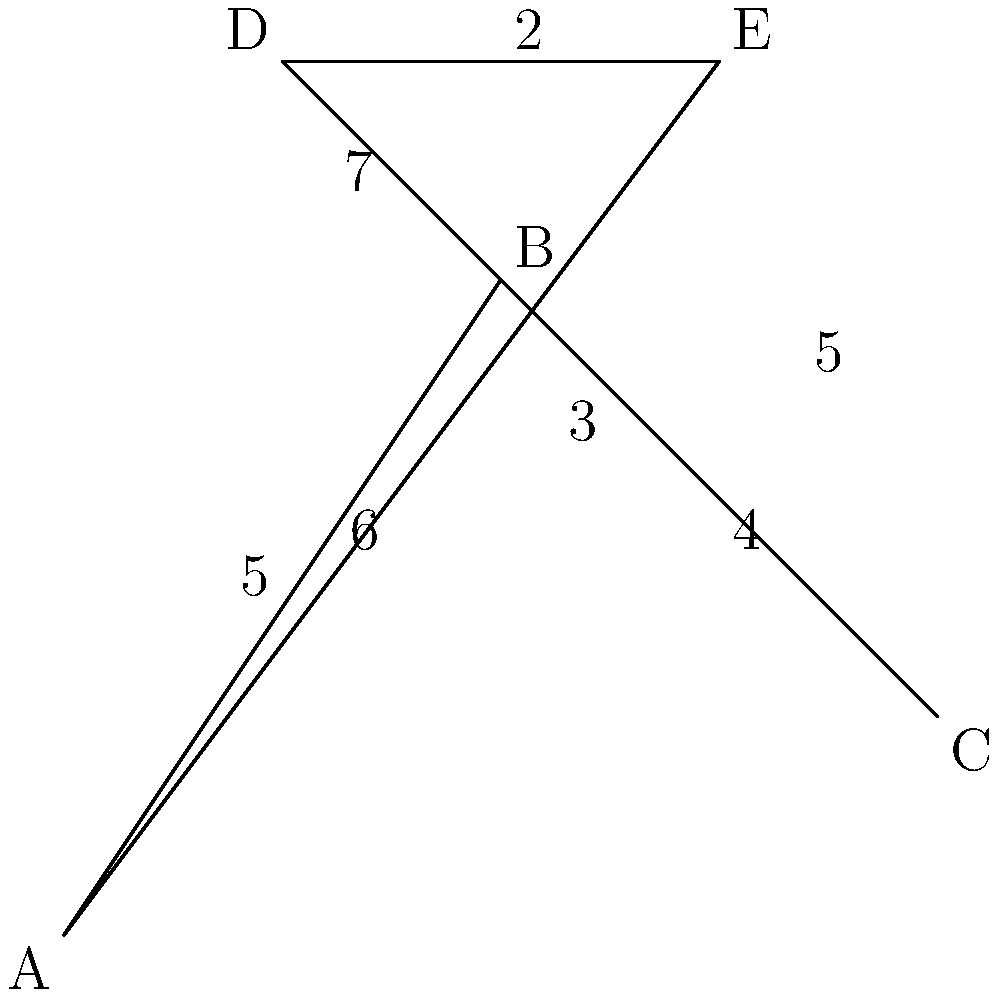Given the map of coffee bean distribution centers (A, B, C, D, E) with distances between them, what is the shortest route that visits all centers exactly once and returns to the starting point? Provide the route and its total distance. To solve this problem, we need to find the shortest Hamiltonian cycle, also known as the Traveling Salesman Problem (TSP). Here's a step-by-step approach:

1. Identify all possible routes:
   There are $(5-1)! = 24$ possible routes, as we can start from any point.

2. Calculate the distance for each route:
   For example, A-B-C-D-E-A = 5 + 4 + 3 + 2 + 6 = 20

3. Compare all routes to find the shortest:
   After calculating all routes, we find that the shortest is:

   A-E-D-B-C-A = 6 + 2 + 7 + 4 + 4 = 23

4. Verify that this route visits each center once and returns to the start.

The shortest route is A-E-D-B-C-A with a total distance of 23 units.

Note: In real-world applications, for larger networks, we would use more advanced algorithms like the Lin-Kernighan heuristic or genetic algorithms to solve the TSP efficiently.
Answer: A-E-D-B-C-A, 23 units 